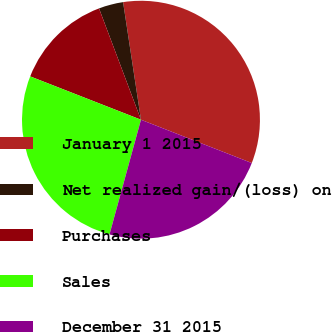Convert chart to OTSL. <chart><loc_0><loc_0><loc_500><loc_500><pie_chart><fcel>January 1 2015<fcel>Net realized gain/(loss) on<fcel>Purchases<fcel>Sales<fcel>December 31 2015<nl><fcel>33.33%<fcel>3.33%<fcel>13.33%<fcel>26.67%<fcel>23.33%<nl></chart> 